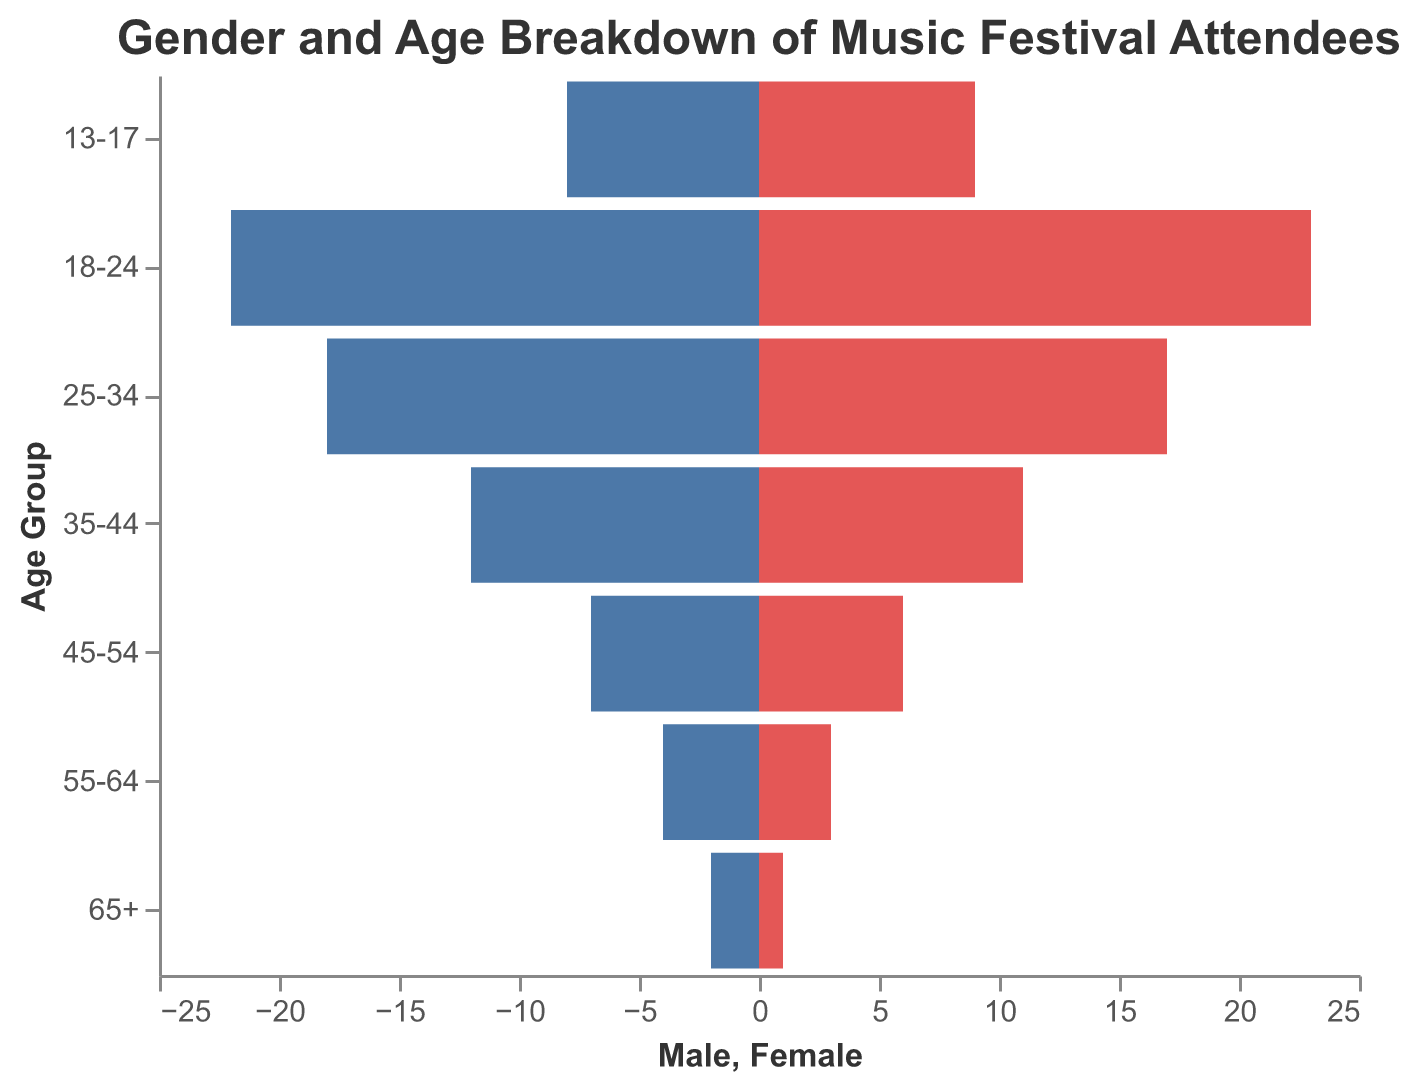What is the title of the figure? The title of the figure is usually located at the top and provides an overview of what the chart is about.
Answer: Gender and Age Breakdown of Music Festival Attendees Which age group has the highest number of female attendees? To determine this, look for the longest red bar on the right side, which represents female attendees.
Answer: 18-24 How many male attendees are there in the 35-44 age group? Find the "35-44" age group on the y-axis and look at the length of the blue bar that extends to the left.
Answer: 12 Which age group has the smallest difference in the number of male and female attendees? Calculate the difference between the lengths of the blue and red bars for each age group. The group with the smallest difference is the correct answer.
Answer: 18-24 What is the total number of male attendees across all age groups? To find this, sum up the number of male attendees from each age group: 2 + 4 + 7 + 12 + 18 + 22 + 8.
Answer: 73 What is the combined number of attendees (both male and female) in the 55-64 age group? Add the number of male attendees (4) and female attendees (3) in the 55-64 age group.
Answer: 7 How does the number of female attendees in the 13-17 age group compare to the number of male attendees in the same group? Compare the lengths of the red bar (females) and the blue bar (males) for the 13-17 age group.
Answer: Female attendees are 1 more than male attendees Which age group shows the greatest gender balance (closest to equal number of male and female attendees)? Identify the age group where the blue and red bars are most similar in length. This indicates a similar number of male and female attendees.
Answer: 65+ What is the total number of attendees aged 18-34 across both genders? Sum the number of male and female attendees in the 18-24 and 25-34 age groups. For 18-24: 22 (male) + 23 (female) = 45. For 25-34: 18 (male) + 17 (female) = 35. Then add these sums: 45 + 35.
Answer: 80 Which age group has the highest overall attendance, combining both genders? Sum the number of male and female attendees for each age group and identify the age group with the highest total.
Answer: 18-24 